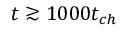<formula> <loc_0><loc_0><loc_500><loc_500>t \gtrsim 1 0 0 0 t _ { c h }</formula> 